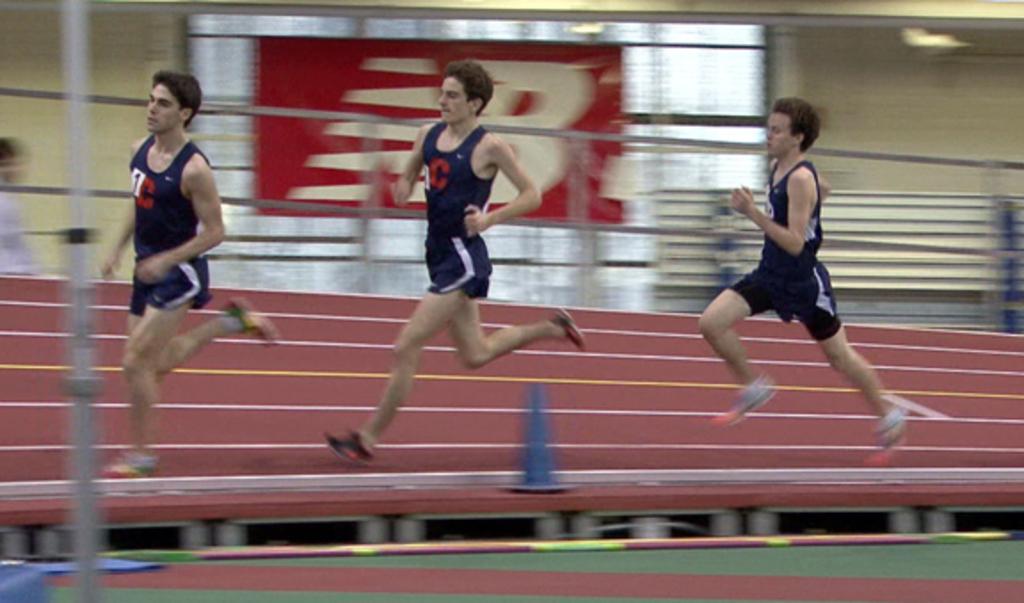In one or two sentences, can you explain what this image depicts? In this image, we can see people running and in the background, there is a board and a wall. In the center, we can see a divider cone and on the left, there is a pole. At the bottom, there is ground. 